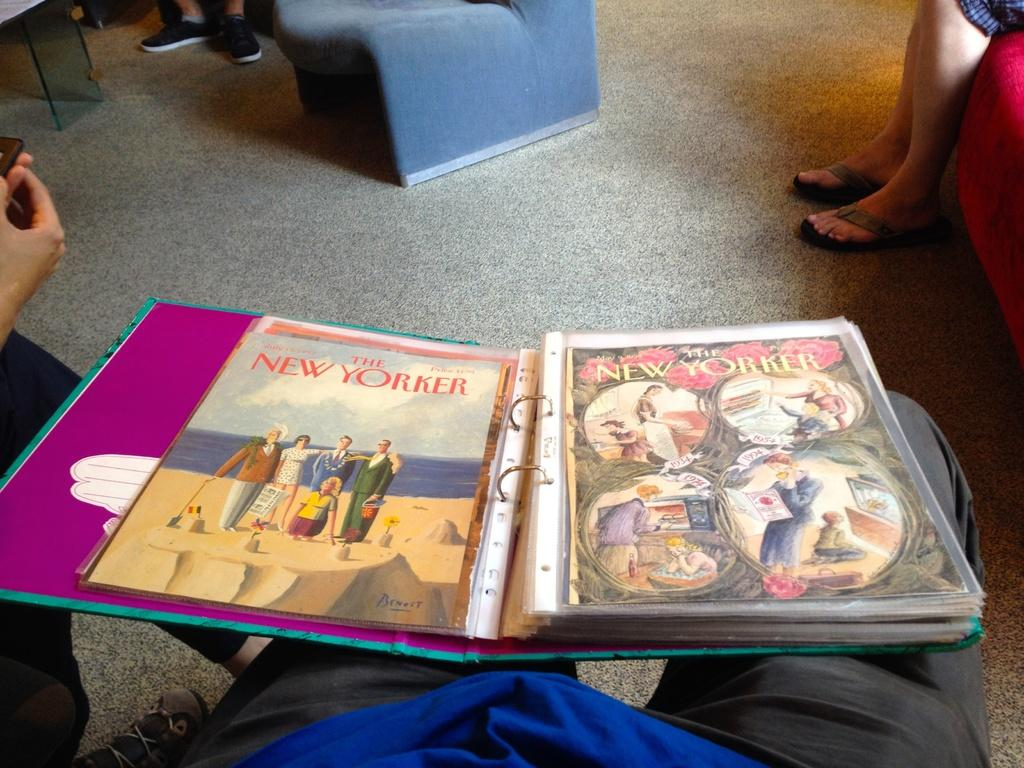<image>
Create a compact narrative representing the image presented. A binder contains copies of the New Yorker magazine. 